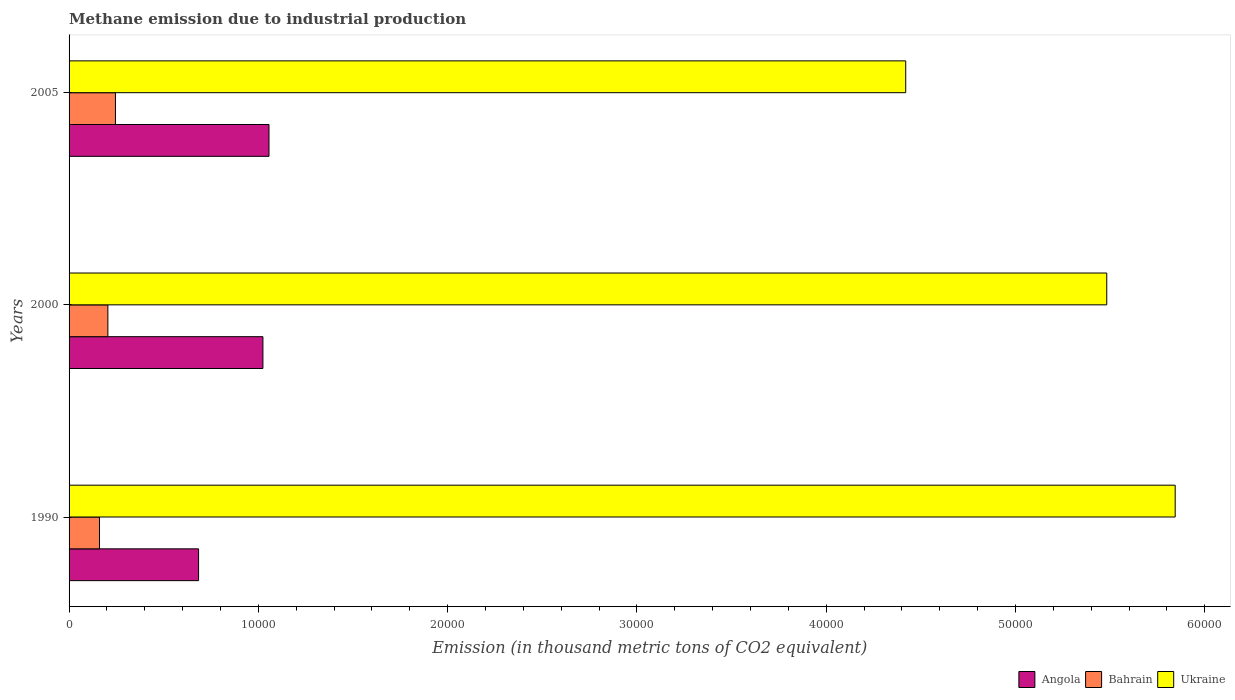How many groups of bars are there?
Give a very brief answer. 3. Are the number of bars per tick equal to the number of legend labels?
Make the answer very short. Yes. How many bars are there on the 2nd tick from the top?
Your answer should be very brief. 3. How many bars are there on the 1st tick from the bottom?
Your response must be concise. 3. What is the label of the 3rd group of bars from the top?
Your answer should be compact. 1990. What is the amount of methane emitted in Ukraine in 2005?
Make the answer very short. 4.42e+04. Across all years, what is the maximum amount of methane emitted in Bahrain?
Ensure brevity in your answer.  2450.6. Across all years, what is the minimum amount of methane emitted in Ukraine?
Your answer should be very brief. 4.42e+04. In which year was the amount of methane emitted in Bahrain maximum?
Offer a terse response. 2005. What is the total amount of methane emitted in Bahrain in the graph?
Your answer should be very brief. 6108.2. What is the difference between the amount of methane emitted in Angola in 2000 and that in 2005?
Ensure brevity in your answer.  -321.6. What is the difference between the amount of methane emitted in Bahrain in 1990 and the amount of methane emitted in Ukraine in 2000?
Offer a terse response. -5.32e+04. What is the average amount of methane emitted in Bahrain per year?
Your answer should be very brief. 2036.07. In the year 2005, what is the difference between the amount of methane emitted in Angola and amount of methane emitted in Bahrain?
Offer a very short reply. 8111.8. What is the ratio of the amount of methane emitted in Bahrain in 1990 to that in 2000?
Offer a terse response. 0.78. Is the amount of methane emitted in Ukraine in 1990 less than that in 2005?
Your answer should be compact. No. Is the difference between the amount of methane emitted in Angola in 2000 and 2005 greater than the difference between the amount of methane emitted in Bahrain in 2000 and 2005?
Make the answer very short. Yes. What is the difference between the highest and the second highest amount of methane emitted in Ukraine?
Offer a very short reply. 3615.2. What is the difference between the highest and the lowest amount of methane emitted in Angola?
Offer a very short reply. 3720.7. What does the 1st bar from the top in 2000 represents?
Provide a short and direct response. Ukraine. What does the 1st bar from the bottom in 1990 represents?
Your answer should be very brief. Angola. How many bars are there?
Provide a succinct answer. 9. Are all the bars in the graph horizontal?
Offer a terse response. Yes. How many years are there in the graph?
Keep it short and to the point. 3. What is the difference between two consecutive major ticks on the X-axis?
Give a very brief answer. 10000. What is the title of the graph?
Give a very brief answer. Methane emission due to industrial production. Does "South Asia" appear as one of the legend labels in the graph?
Your answer should be compact. No. What is the label or title of the X-axis?
Give a very brief answer. Emission (in thousand metric tons of CO2 equivalent). What is the label or title of the Y-axis?
Keep it short and to the point. Years. What is the Emission (in thousand metric tons of CO2 equivalent) in Angola in 1990?
Give a very brief answer. 6841.7. What is the Emission (in thousand metric tons of CO2 equivalent) in Bahrain in 1990?
Provide a succinct answer. 1607.3. What is the Emission (in thousand metric tons of CO2 equivalent) in Ukraine in 1990?
Offer a very short reply. 5.84e+04. What is the Emission (in thousand metric tons of CO2 equivalent) in Angola in 2000?
Provide a short and direct response. 1.02e+04. What is the Emission (in thousand metric tons of CO2 equivalent) in Bahrain in 2000?
Your answer should be compact. 2050.3. What is the Emission (in thousand metric tons of CO2 equivalent) of Ukraine in 2000?
Provide a short and direct response. 5.48e+04. What is the Emission (in thousand metric tons of CO2 equivalent) in Angola in 2005?
Your answer should be compact. 1.06e+04. What is the Emission (in thousand metric tons of CO2 equivalent) in Bahrain in 2005?
Offer a terse response. 2450.6. What is the Emission (in thousand metric tons of CO2 equivalent) in Ukraine in 2005?
Provide a succinct answer. 4.42e+04. Across all years, what is the maximum Emission (in thousand metric tons of CO2 equivalent) in Angola?
Give a very brief answer. 1.06e+04. Across all years, what is the maximum Emission (in thousand metric tons of CO2 equivalent) in Bahrain?
Your answer should be compact. 2450.6. Across all years, what is the maximum Emission (in thousand metric tons of CO2 equivalent) in Ukraine?
Offer a terse response. 5.84e+04. Across all years, what is the minimum Emission (in thousand metric tons of CO2 equivalent) of Angola?
Keep it short and to the point. 6841.7. Across all years, what is the minimum Emission (in thousand metric tons of CO2 equivalent) of Bahrain?
Provide a succinct answer. 1607.3. Across all years, what is the minimum Emission (in thousand metric tons of CO2 equivalent) in Ukraine?
Provide a succinct answer. 4.42e+04. What is the total Emission (in thousand metric tons of CO2 equivalent) of Angola in the graph?
Your answer should be compact. 2.76e+04. What is the total Emission (in thousand metric tons of CO2 equivalent) in Bahrain in the graph?
Offer a terse response. 6108.2. What is the total Emission (in thousand metric tons of CO2 equivalent) of Ukraine in the graph?
Keep it short and to the point. 1.57e+05. What is the difference between the Emission (in thousand metric tons of CO2 equivalent) in Angola in 1990 and that in 2000?
Keep it short and to the point. -3399.1. What is the difference between the Emission (in thousand metric tons of CO2 equivalent) in Bahrain in 1990 and that in 2000?
Provide a succinct answer. -443. What is the difference between the Emission (in thousand metric tons of CO2 equivalent) of Ukraine in 1990 and that in 2000?
Your response must be concise. 3615.2. What is the difference between the Emission (in thousand metric tons of CO2 equivalent) of Angola in 1990 and that in 2005?
Offer a terse response. -3720.7. What is the difference between the Emission (in thousand metric tons of CO2 equivalent) of Bahrain in 1990 and that in 2005?
Give a very brief answer. -843.3. What is the difference between the Emission (in thousand metric tons of CO2 equivalent) in Ukraine in 1990 and that in 2005?
Your answer should be compact. 1.42e+04. What is the difference between the Emission (in thousand metric tons of CO2 equivalent) in Angola in 2000 and that in 2005?
Offer a terse response. -321.6. What is the difference between the Emission (in thousand metric tons of CO2 equivalent) of Bahrain in 2000 and that in 2005?
Your answer should be very brief. -400.3. What is the difference between the Emission (in thousand metric tons of CO2 equivalent) of Ukraine in 2000 and that in 2005?
Keep it short and to the point. 1.06e+04. What is the difference between the Emission (in thousand metric tons of CO2 equivalent) of Angola in 1990 and the Emission (in thousand metric tons of CO2 equivalent) of Bahrain in 2000?
Offer a very short reply. 4791.4. What is the difference between the Emission (in thousand metric tons of CO2 equivalent) of Angola in 1990 and the Emission (in thousand metric tons of CO2 equivalent) of Ukraine in 2000?
Your response must be concise. -4.80e+04. What is the difference between the Emission (in thousand metric tons of CO2 equivalent) in Bahrain in 1990 and the Emission (in thousand metric tons of CO2 equivalent) in Ukraine in 2000?
Provide a short and direct response. -5.32e+04. What is the difference between the Emission (in thousand metric tons of CO2 equivalent) of Angola in 1990 and the Emission (in thousand metric tons of CO2 equivalent) of Bahrain in 2005?
Your response must be concise. 4391.1. What is the difference between the Emission (in thousand metric tons of CO2 equivalent) of Angola in 1990 and the Emission (in thousand metric tons of CO2 equivalent) of Ukraine in 2005?
Your response must be concise. -3.74e+04. What is the difference between the Emission (in thousand metric tons of CO2 equivalent) in Bahrain in 1990 and the Emission (in thousand metric tons of CO2 equivalent) in Ukraine in 2005?
Make the answer very short. -4.26e+04. What is the difference between the Emission (in thousand metric tons of CO2 equivalent) of Angola in 2000 and the Emission (in thousand metric tons of CO2 equivalent) of Bahrain in 2005?
Your answer should be very brief. 7790.2. What is the difference between the Emission (in thousand metric tons of CO2 equivalent) in Angola in 2000 and the Emission (in thousand metric tons of CO2 equivalent) in Ukraine in 2005?
Provide a succinct answer. -3.40e+04. What is the difference between the Emission (in thousand metric tons of CO2 equivalent) in Bahrain in 2000 and the Emission (in thousand metric tons of CO2 equivalent) in Ukraine in 2005?
Your answer should be compact. -4.21e+04. What is the average Emission (in thousand metric tons of CO2 equivalent) of Angola per year?
Your answer should be very brief. 9214.97. What is the average Emission (in thousand metric tons of CO2 equivalent) of Bahrain per year?
Keep it short and to the point. 2036.07. What is the average Emission (in thousand metric tons of CO2 equivalent) in Ukraine per year?
Provide a succinct answer. 5.25e+04. In the year 1990, what is the difference between the Emission (in thousand metric tons of CO2 equivalent) of Angola and Emission (in thousand metric tons of CO2 equivalent) of Bahrain?
Provide a succinct answer. 5234.4. In the year 1990, what is the difference between the Emission (in thousand metric tons of CO2 equivalent) of Angola and Emission (in thousand metric tons of CO2 equivalent) of Ukraine?
Offer a very short reply. -5.16e+04. In the year 1990, what is the difference between the Emission (in thousand metric tons of CO2 equivalent) of Bahrain and Emission (in thousand metric tons of CO2 equivalent) of Ukraine?
Make the answer very short. -5.68e+04. In the year 2000, what is the difference between the Emission (in thousand metric tons of CO2 equivalent) in Angola and Emission (in thousand metric tons of CO2 equivalent) in Bahrain?
Your answer should be compact. 8190.5. In the year 2000, what is the difference between the Emission (in thousand metric tons of CO2 equivalent) of Angola and Emission (in thousand metric tons of CO2 equivalent) of Ukraine?
Make the answer very short. -4.46e+04. In the year 2000, what is the difference between the Emission (in thousand metric tons of CO2 equivalent) in Bahrain and Emission (in thousand metric tons of CO2 equivalent) in Ukraine?
Your answer should be compact. -5.28e+04. In the year 2005, what is the difference between the Emission (in thousand metric tons of CO2 equivalent) in Angola and Emission (in thousand metric tons of CO2 equivalent) in Bahrain?
Give a very brief answer. 8111.8. In the year 2005, what is the difference between the Emission (in thousand metric tons of CO2 equivalent) in Angola and Emission (in thousand metric tons of CO2 equivalent) in Ukraine?
Make the answer very short. -3.36e+04. In the year 2005, what is the difference between the Emission (in thousand metric tons of CO2 equivalent) of Bahrain and Emission (in thousand metric tons of CO2 equivalent) of Ukraine?
Your answer should be very brief. -4.17e+04. What is the ratio of the Emission (in thousand metric tons of CO2 equivalent) of Angola in 1990 to that in 2000?
Make the answer very short. 0.67. What is the ratio of the Emission (in thousand metric tons of CO2 equivalent) in Bahrain in 1990 to that in 2000?
Your answer should be very brief. 0.78. What is the ratio of the Emission (in thousand metric tons of CO2 equivalent) of Ukraine in 1990 to that in 2000?
Offer a terse response. 1.07. What is the ratio of the Emission (in thousand metric tons of CO2 equivalent) in Angola in 1990 to that in 2005?
Your answer should be very brief. 0.65. What is the ratio of the Emission (in thousand metric tons of CO2 equivalent) in Bahrain in 1990 to that in 2005?
Give a very brief answer. 0.66. What is the ratio of the Emission (in thousand metric tons of CO2 equivalent) of Ukraine in 1990 to that in 2005?
Provide a succinct answer. 1.32. What is the ratio of the Emission (in thousand metric tons of CO2 equivalent) in Angola in 2000 to that in 2005?
Make the answer very short. 0.97. What is the ratio of the Emission (in thousand metric tons of CO2 equivalent) in Bahrain in 2000 to that in 2005?
Provide a succinct answer. 0.84. What is the ratio of the Emission (in thousand metric tons of CO2 equivalent) of Ukraine in 2000 to that in 2005?
Ensure brevity in your answer.  1.24. What is the difference between the highest and the second highest Emission (in thousand metric tons of CO2 equivalent) in Angola?
Your answer should be very brief. 321.6. What is the difference between the highest and the second highest Emission (in thousand metric tons of CO2 equivalent) of Bahrain?
Offer a very short reply. 400.3. What is the difference between the highest and the second highest Emission (in thousand metric tons of CO2 equivalent) in Ukraine?
Make the answer very short. 3615.2. What is the difference between the highest and the lowest Emission (in thousand metric tons of CO2 equivalent) in Angola?
Make the answer very short. 3720.7. What is the difference between the highest and the lowest Emission (in thousand metric tons of CO2 equivalent) in Bahrain?
Provide a short and direct response. 843.3. What is the difference between the highest and the lowest Emission (in thousand metric tons of CO2 equivalent) of Ukraine?
Your answer should be very brief. 1.42e+04. 